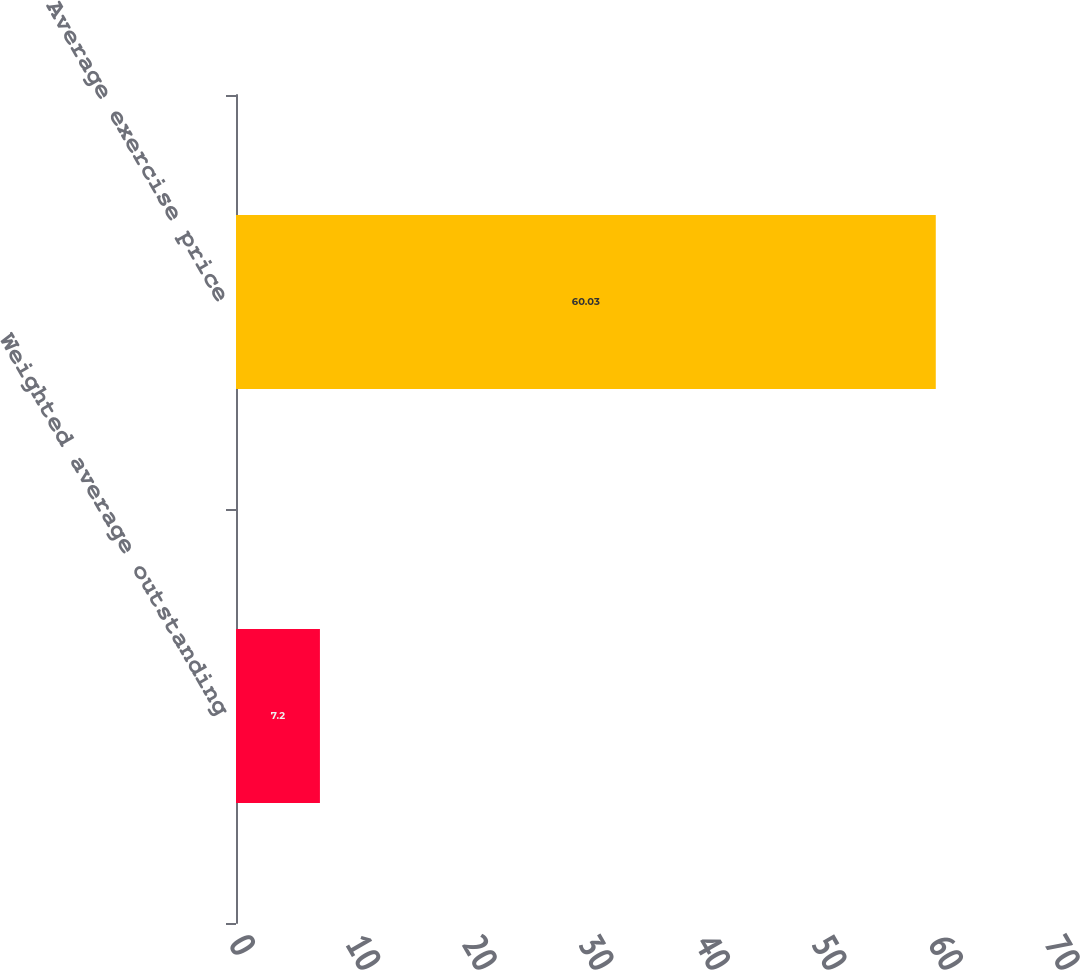<chart> <loc_0><loc_0><loc_500><loc_500><bar_chart><fcel>Weighted average outstanding<fcel>Average exercise price<nl><fcel>7.2<fcel>60.03<nl></chart> 